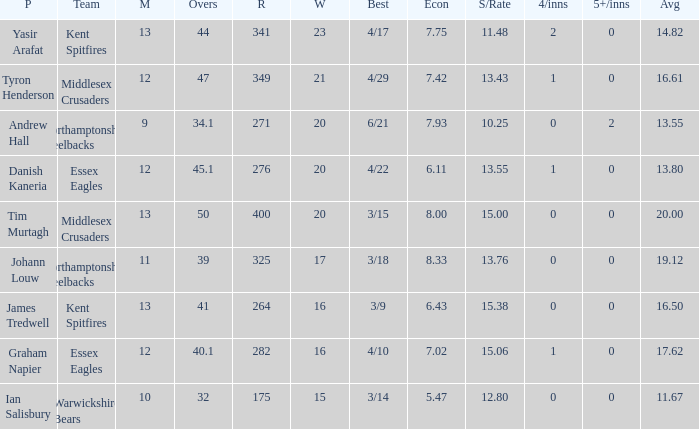Name the least matches for runs being 276 12.0. 